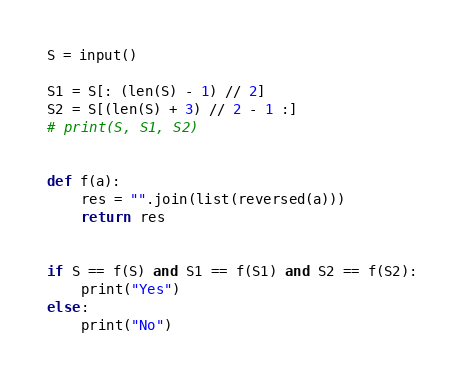Convert code to text. <code><loc_0><loc_0><loc_500><loc_500><_Python_>S = input()

S1 = S[: (len(S) - 1) // 2]
S2 = S[(len(S) + 3) // 2 - 1 :]
# print(S, S1, S2)


def f(a):
    res = "".join(list(reversed(a)))
    return res


if S == f(S) and S1 == f(S1) and S2 == f(S2):
    print("Yes")
else:
    print("No")
</code> 